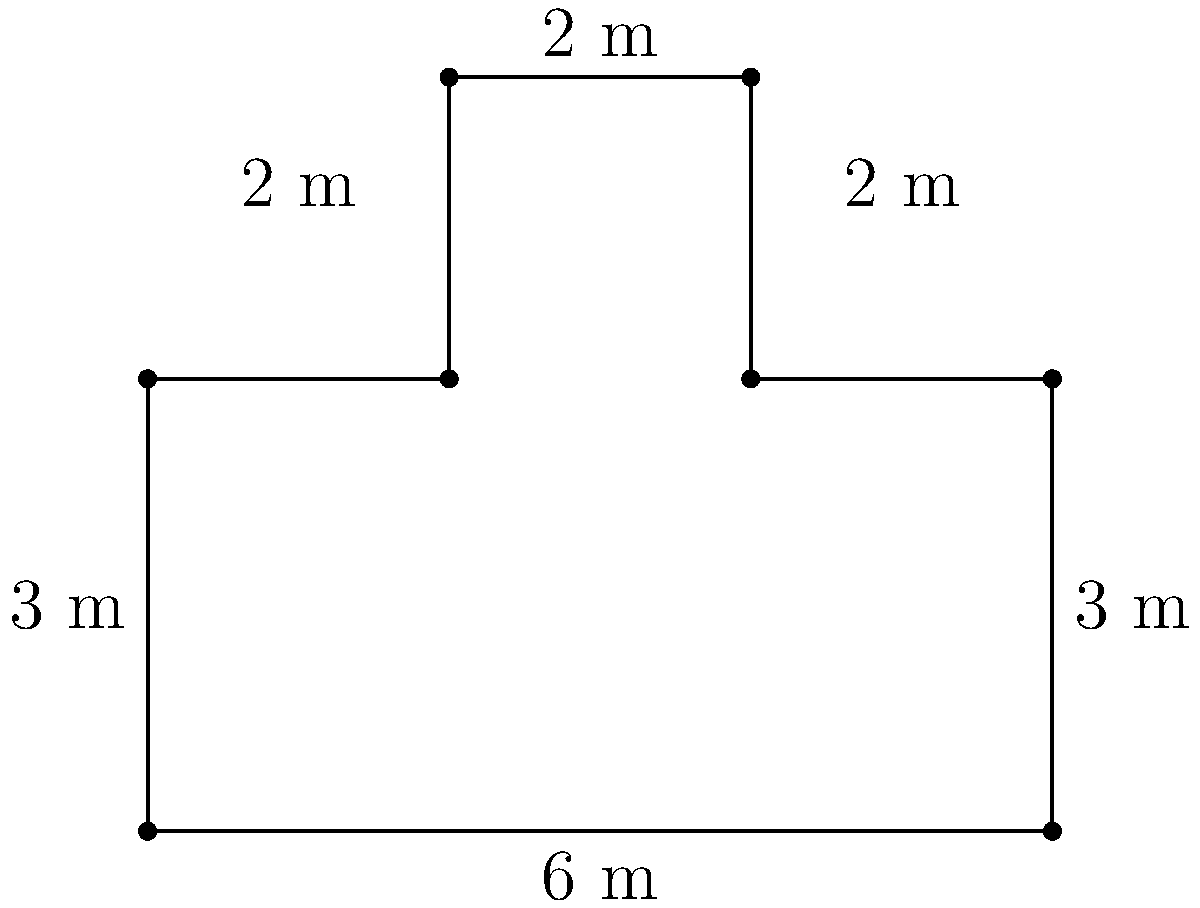As a data analyst working on enhancing national security, you're tasked with calculating the area of a sensitive location with an irregular shape. The location's perimeter is represented by the figure above, where all angles are right angles. What is the total area of this location in square meters? To calculate the area of this irregular shape, we can break it down into rectangles:

1. The main rectangle:
   Length = 6 m, Width = 3 m
   Area = $6 \times 3 = 18$ m²

2. The upper-right rectangle:
   Length = 2 m, Width = 2 m
   Area = $2 \times 2 = 4$ m²

3. The upper-left rectangle:
   Length = 2 m, Width = 2 m
   Area = $2 \times 2 = 4$ m²

Total area:
$$\text{Total Area} = 18 + 4 + 4 = 26 \text{ m²}$$

Alternatively, we can subtract the missing areas from a larger rectangle:

1. Large rectangle:
   Length = 6 m, Width = 5 m
   Area = $6 \times 5 = 30$ m²

2. Missing upper-middle rectangle:
   Length = 2 m, Width = 2 m
   Area = $2 \times 2 = 4$ m²

Total area:
$$\text{Total Area} = 30 - 4 = 26 \text{ m²}$$

Both methods yield the same result, confirming the accuracy of our calculation.
Answer: 26 m² 